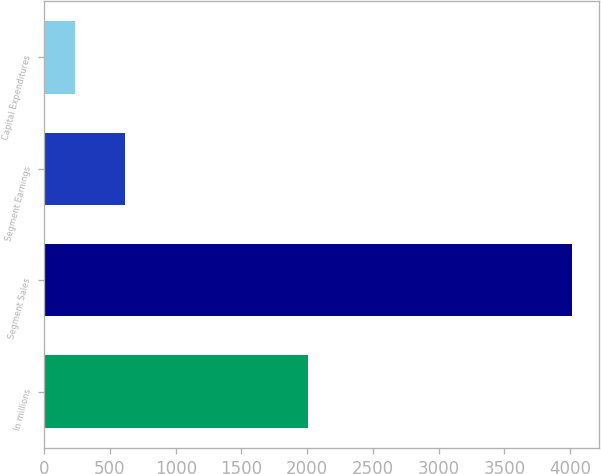<chart> <loc_0><loc_0><loc_500><loc_500><bar_chart><fcel>In millions<fcel>Segment Sales<fcel>Segment Earnings<fcel>Capital Expenditures<nl><fcel>2010<fcel>4016<fcel>614.9<fcel>237<nl></chart> 